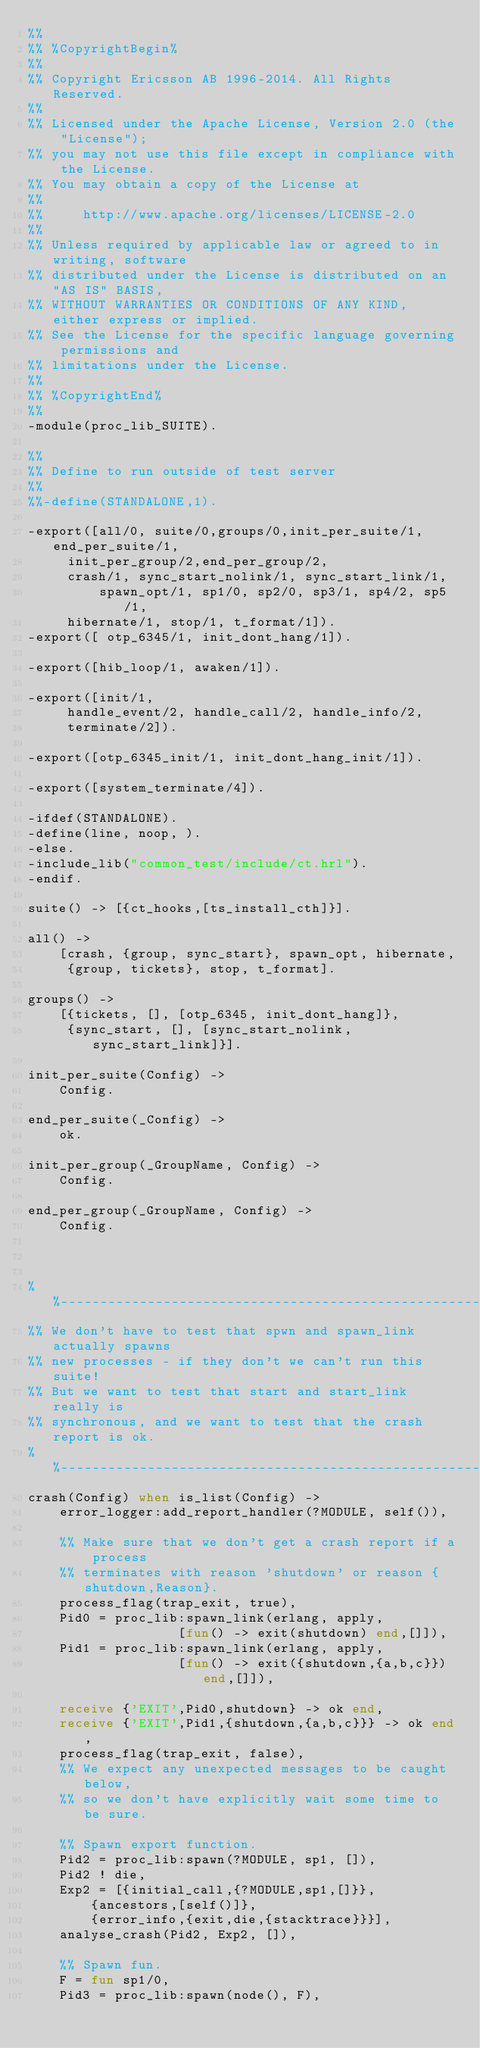<code> <loc_0><loc_0><loc_500><loc_500><_Erlang_>%%
%% %CopyrightBegin%
%% 
%% Copyright Ericsson AB 1996-2014. All Rights Reserved.
%% 
%% Licensed under the Apache License, Version 2.0 (the "License");
%% you may not use this file except in compliance with the License.
%% You may obtain a copy of the License at
%%
%%     http://www.apache.org/licenses/LICENSE-2.0
%%
%% Unless required by applicable law or agreed to in writing, software
%% distributed under the License is distributed on an "AS IS" BASIS,
%% WITHOUT WARRANTIES OR CONDITIONS OF ANY KIND, either express or implied.
%% See the License for the specific language governing permissions and
%% limitations under the License.
%% 
%% %CopyrightEnd%
%%
-module(proc_lib_SUITE).

%%
%% Define to run outside of test server
%%
%%-define(STANDALONE,1).

-export([all/0, suite/0,groups/0,init_per_suite/1, end_per_suite/1, 
	 init_per_group/2,end_per_group/2, 
	 crash/1, sync_start_nolink/1, sync_start_link/1,
         spawn_opt/1, sp1/0, sp2/0, sp3/1, sp4/2, sp5/1,
	 hibernate/1, stop/1, t_format/1]).
-export([ otp_6345/1, init_dont_hang/1]).

-export([hib_loop/1, awaken/1]).

-export([init/1,
	 handle_event/2, handle_call/2, handle_info/2,
	 terminate/2]).

-export([otp_6345_init/1, init_dont_hang_init/1]).

-export([system_terminate/4]).

-ifdef(STANDALONE).
-define(line, noop, ).
-else.
-include_lib("common_test/include/ct.hrl").
-endif.

suite() -> [{ct_hooks,[ts_install_cth]}].

all() -> 
    [crash, {group, sync_start}, spawn_opt, hibernate,
     {group, tickets}, stop, t_format].

groups() -> 
    [{tickets, [], [otp_6345, init_dont_hang]},
     {sync_start, [], [sync_start_nolink, sync_start_link]}].

init_per_suite(Config) ->
    Config.

end_per_suite(_Config) ->
    ok.

init_per_group(_GroupName, Config) ->
    Config.

end_per_group(_GroupName, Config) ->
    Config.



%%-----------------------------------------------------------------
%% We don't have to test that spwn and spawn_link actually spawns
%% new processes - if they don't we can't run this suite!
%% But we want to test that start and start_link really is
%% synchronous, and we want to test that the crash report is ok.
%%-----------------------------------------------------------------
crash(Config) when is_list(Config) ->
    error_logger:add_report_handler(?MODULE, self()),

    %% Make sure that we don't get a crash report if a process
    %% terminates with reason 'shutdown' or reason {shutdown,Reason}.
    process_flag(trap_exit, true),
    Pid0 = proc_lib:spawn_link(erlang, apply,
			       [fun() -> exit(shutdown) end,[]]),
    Pid1 = proc_lib:spawn_link(erlang, apply,
			       [fun() -> exit({shutdown,{a,b,c}}) end,[]]),

    receive {'EXIT',Pid0,shutdown} -> ok end,
    receive {'EXIT',Pid1,{shutdown,{a,b,c}}} -> ok end,
    process_flag(trap_exit, false),
    %% We expect any unexpected messages to be caught below,
    %% so we don't have explicitly wait some time to be sure.

    %% Spawn export function.
    Pid2 = proc_lib:spawn(?MODULE, sp1, []),
    Pid2 ! die,
    Exp2 = [{initial_call,{?MODULE,sp1,[]}},
	    {ancestors,[self()]},
	    {error_info,{exit,die,{stacktrace}}}],
    analyse_crash(Pid2, Exp2, []),

    %% Spawn fun.
    F = fun sp1/0,
    Pid3 = proc_lib:spawn(node(), F),</code> 